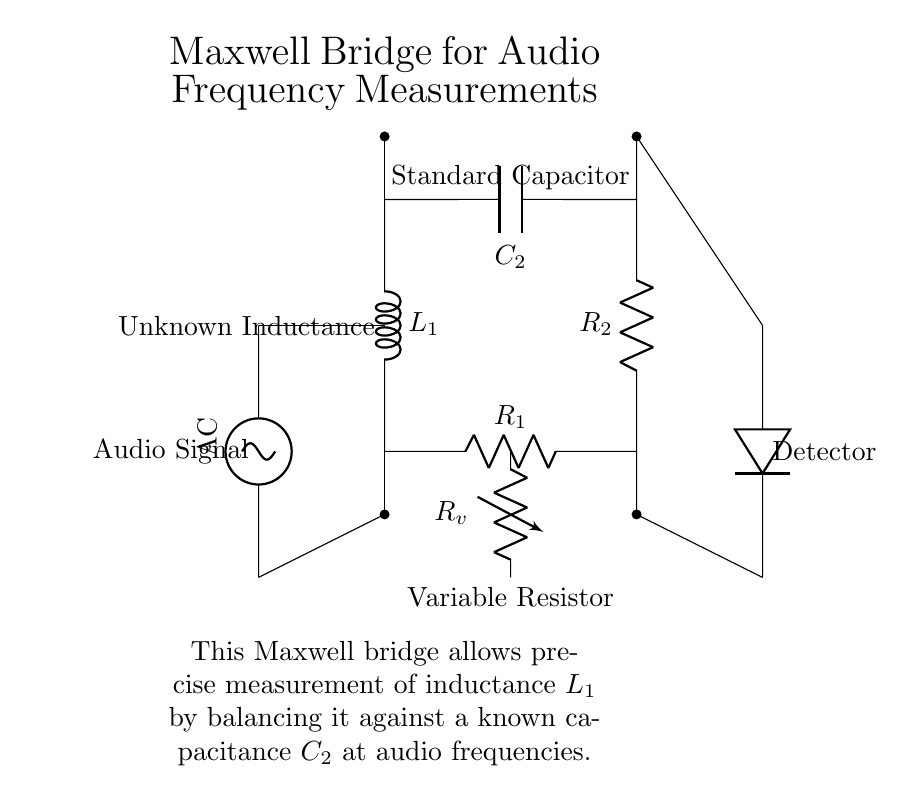What is the function of the variable resistor in this circuit? The variable resistor adjusts the resistance value, allowing for balancing the bridge circuit. This is essential for achieving accurate measurements of the unknown inductance by fine-tuning until the detector indicates balance.
Answer: Adjusts resistance What component is used to measure the unknown inductance? The unknown inductance is represented by the inductor labeled as L1, which is balanced against the known capacitance to determine its value accurately.
Answer: L1 What type of source is used in the circuit? The circuit employs a sinusoidal voltage source, indicated by the labeling 'AC' near the source, which provides alternating current for measurement purposes.
Answer: AC How many resistors are present in the Maxwell bridge? There are two resistors in the circuit: R1, which is a fixed resistor, and Rv, which is a variable resistor. Both play roles in balancing the bridge for precise measurements.
Answer: Two What role does the detector play in this circuit? The detector measures the output signal, indicating when the bridge is balanced, allowing for direct readings of inductance once balance is achieved between the resistive and reactive components.
Answer: Measures output Why is there a capacitive component in the Maxwell bridge? The capacitor (C2) provides a known reactance that is used to balance the inductive reactance of L1 in the circuit, which is crucial for precise measurement of the unknown inductance at audio frequencies.
Answer: To balance inductance What is the purpose of this Maxwell bridge circuit? The purpose of this circuit is to measure the unknown inductance L1 by balancing it against a known capacitive reactance, facilitating precise measurements necessary in audio frequency applications.
Answer: To measure inductance 